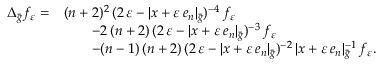Convert formula to latex. <formula><loc_0><loc_0><loc_500><loc_500>\begin{array} { r l } { \Delta _ { \bar { g } } f _ { \varepsilon } = } & { ( n + 2 ) ^ { 2 } \, ( 2 \, \varepsilon - | x + \varepsilon \, e _ { n } | _ { \bar { g } } ) ^ { - 4 } \, f _ { \varepsilon } } \\ & { \quad - 2 \, ( n + 2 ) \, ( 2 \, \varepsilon - | x + \varepsilon \, e _ { n } | _ { \bar { g } } ) ^ { - 3 } \, f _ { \varepsilon } } \\ & { \quad - ( n - 1 ) \, ( n + 2 ) \, ( 2 \, \varepsilon - | x + \varepsilon \, e _ { n } | _ { \bar { g } } ) ^ { - 2 } \, | x + \varepsilon \, e _ { n } | _ { \bar { g } } ^ { - 1 } \, f _ { \varepsilon } . } \end{array}</formula> 